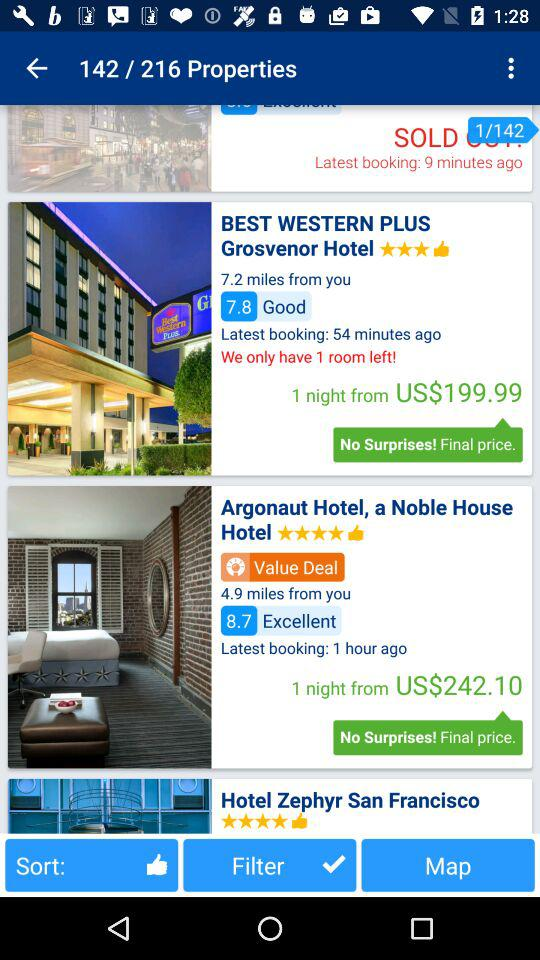What is the rating for the Argonaut Hotel, a noble house? The rating is 4 stars. 